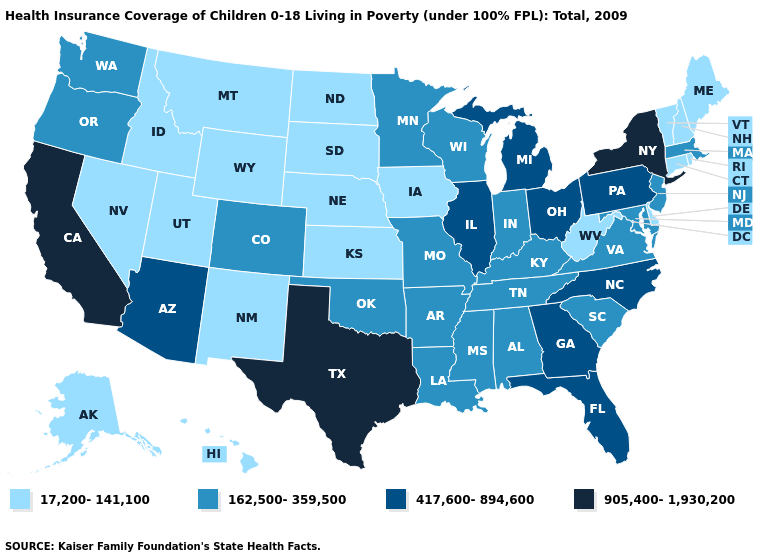What is the value of Ohio?
Keep it brief. 417,600-894,600. Name the states that have a value in the range 17,200-141,100?
Keep it brief. Alaska, Connecticut, Delaware, Hawaii, Idaho, Iowa, Kansas, Maine, Montana, Nebraska, Nevada, New Hampshire, New Mexico, North Dakota, Rhode Island, South Dakota, Utah, Vermont, West Virginia, Wyoming. Does Pennsylvania have the same value as Arizona?
Concise answer only. Yes. Does California have the same value as New York?
Short answer required. Yes. Among the states that border New York , which have the highest value?
Answer briefly. Pennsylvania. What is the value of Connecticut?
Short answer required. 17,200-141,100. Which states have the lowest value in the USA?
Be succinct. Alaska, Connecticut, Delaware, Hawaii, Idaho, Iowa, Kansas, Maine, Montana, Nebraska, Nevada, New Hampshire, New Mexico, North Dakota, Rhode Island, South Dakota, Utah, Vermont, West Virginia, Wyoming. Among the states that border Oregon , does California have the highest value?
Quick response, please. Yes. What is the lowest value in the MidWest?
Answer briefly. 17,200-141,100. Among the states that border Washington , does Idaho have the highest value?
Keep it brief. No. Which states have the lowest value in the USA?
Answer briefly. Alaska, Connecticut, Delaware, Hawaii, Idaho, Iowa, Kansas, Maine, Montana, Nebraska, Nevada, New Hampshire, New Mexico, North Dakota, Rhode Island, South Dakota, Utah, Vermont, West Virginia, Wyoming. Does Texas have the highest value in the USA?
Answer briefly. Yes. Name the states that have a value in the range 417,600-894,600?
Concise answer only. Arizona, Florida, Georgia, Illinois, Michigan, North Carolina, Ohio, Pennsylvania. Name the states that have a value in the range 162,500-359,500?
Give a very brief answer. Alabama, Arkansas, Colorado, Indiana, Kentucky, Louisiana, Maryland, Massachusetts, Minnesota, Mississippi, Missouri, New Jersey, Oklahoma, Oregon, South Carolina, Tennessee, Virginia, Washington, Wisconsin. What is the lowest value in the South?
Short answer required. 17,200-141,100. 